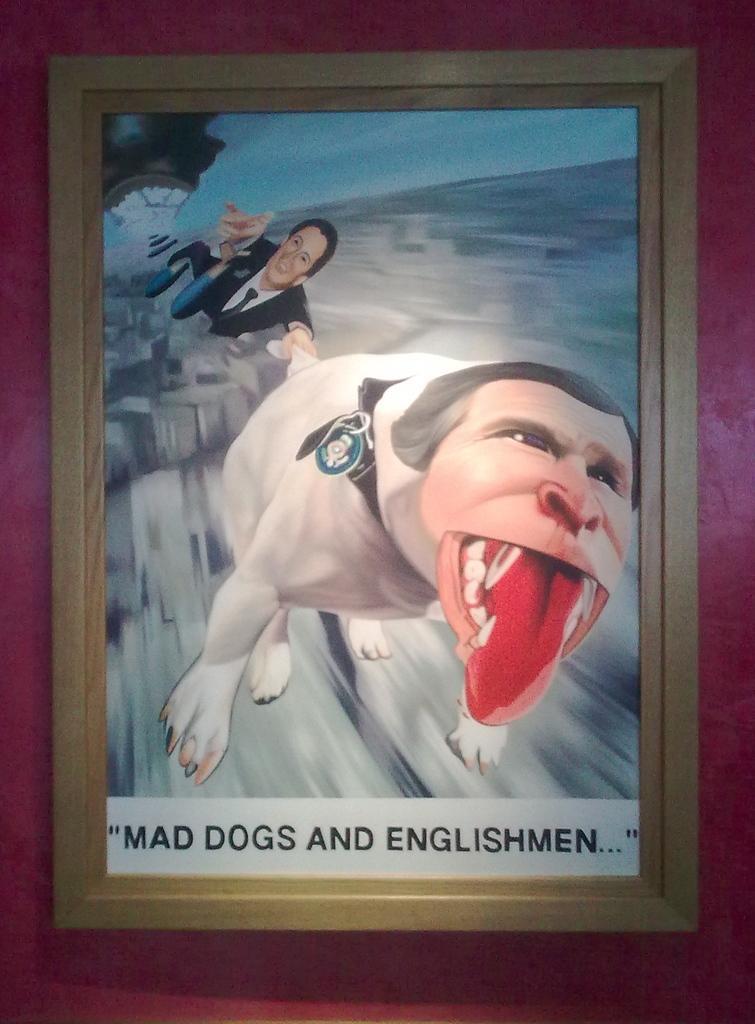Describe this image in one or two sentences. In this image I can see a picture on the wall. Something is written on the picture. In that picture I can see an animated person and animal. In the background of the picture it is blurry.  